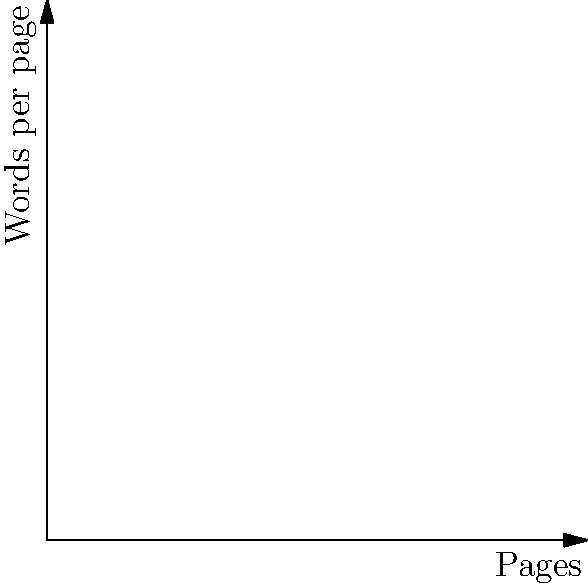In a screenwriting competition, your script (A) has 120 pages with an average of 100 words per page, while your competitor's script (B) has 80 pages with an average of 130 words per page. Using vector subtraction, determine the difference in total word count between your script and your competitor's. What does the resulting vector represent in terms of script comparison? Let's approach this step-by-step:

1) First, let's represent each script as a vector:
   Your script (A): $\vec{A} = (120, 100)$
   Competitor's script (B): $\vec{B} = (80, 130)$

2) The vector subtraction we need to perform is $\vec{A} - \vec{B}$

3) To subtract vectors, we subtract their corresponding components:
   $\vec{A} - \vec{B} = (120 - 80, 100 - 130) = (40, -30)$

4) Now, let's interpret this result:
   - The x-component (40) represents the difference in page count: your script has 40 more pages.
   - The y-component (-30) represents the difference in words per page: your script has 30 fewer words per page on average.

5) To find the difference in total word count, we need to calculate:
   Your total words: $120 \times 100 = 12,000$
   Competitor's total words: $80 \times 130 = 10,400$
   Difference: $12,000 - 10,400 = 1,600$

6) The resulting vector $(40, -30)$ represents the trade-off between page count and word density. It shows that while your script is longer in terms of pages, it's less dense in terms of words per page.
Answer: 1,600 more words; $(40, -30)$ represents 40 more pages but 30 fewer words per page. 